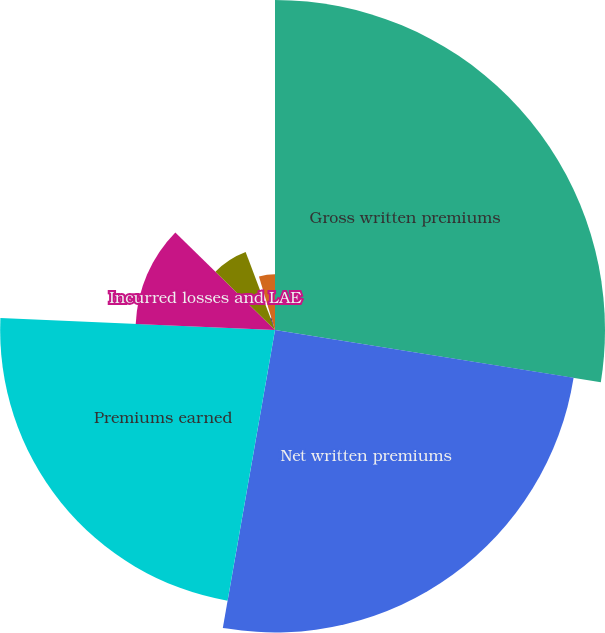Convert chart to OTSL. <chart><loc_0><loc_0><loc_500><loc_500><pie_chart><fcel>Gross written premiums<fcel>Net written premiums<fcel>Premiums earned<fcel>Incurred losses and LAE<fcel>Commission and brokerage<fcel>Other underwriting expenses<fcel>Underwriting gain (loss)<nl><fcel>27.53%<fcel>25.23%<fcel>22.93%<fcel>11.63%<fcel>6.95%<fcel>1.08%<fcel>4.65%<nl></chart> 